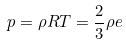<formula> <loc_0><loc_0><loc_500><loc_500>p = \rho R T = \frac { 2 } { 3 } \rho e</formula> 